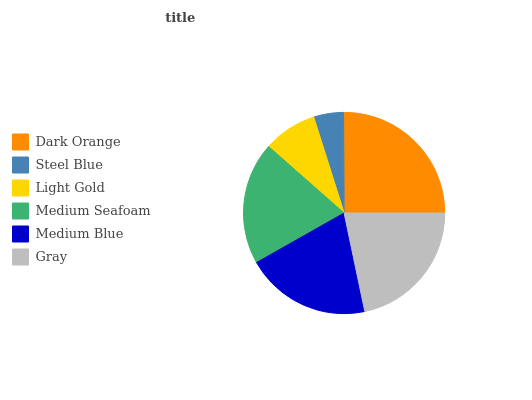Is Steel Blue the minimum?
Answer yes or no. Yes. Is Dark Orange the maximum?
Answer yes or no. Yes. Is Light Gold the minimum?
Answer yes or no. No. Is Light Gold the maximum?
Answer yes or no. No. Is Light Gold greater than Steel Blue?
Answer yes or no. Yes. Is Steel Blue less than Light Gold?
Answer yes or no. Yes. Is Steel Blue greater than Light Gold?
Answer yes or no. No. Is Light Gold less than Steel Blue?
Answer yes or no. No. Is Medium Blue the high median?
Answer yes or no. Yes. Is Medium Seafoam the low median?
Answer yes or no. Yes. Is Light Gold the high median?
Answer yes or no. No. Is Steel Blue the low median?
Answer yes or no. No. 